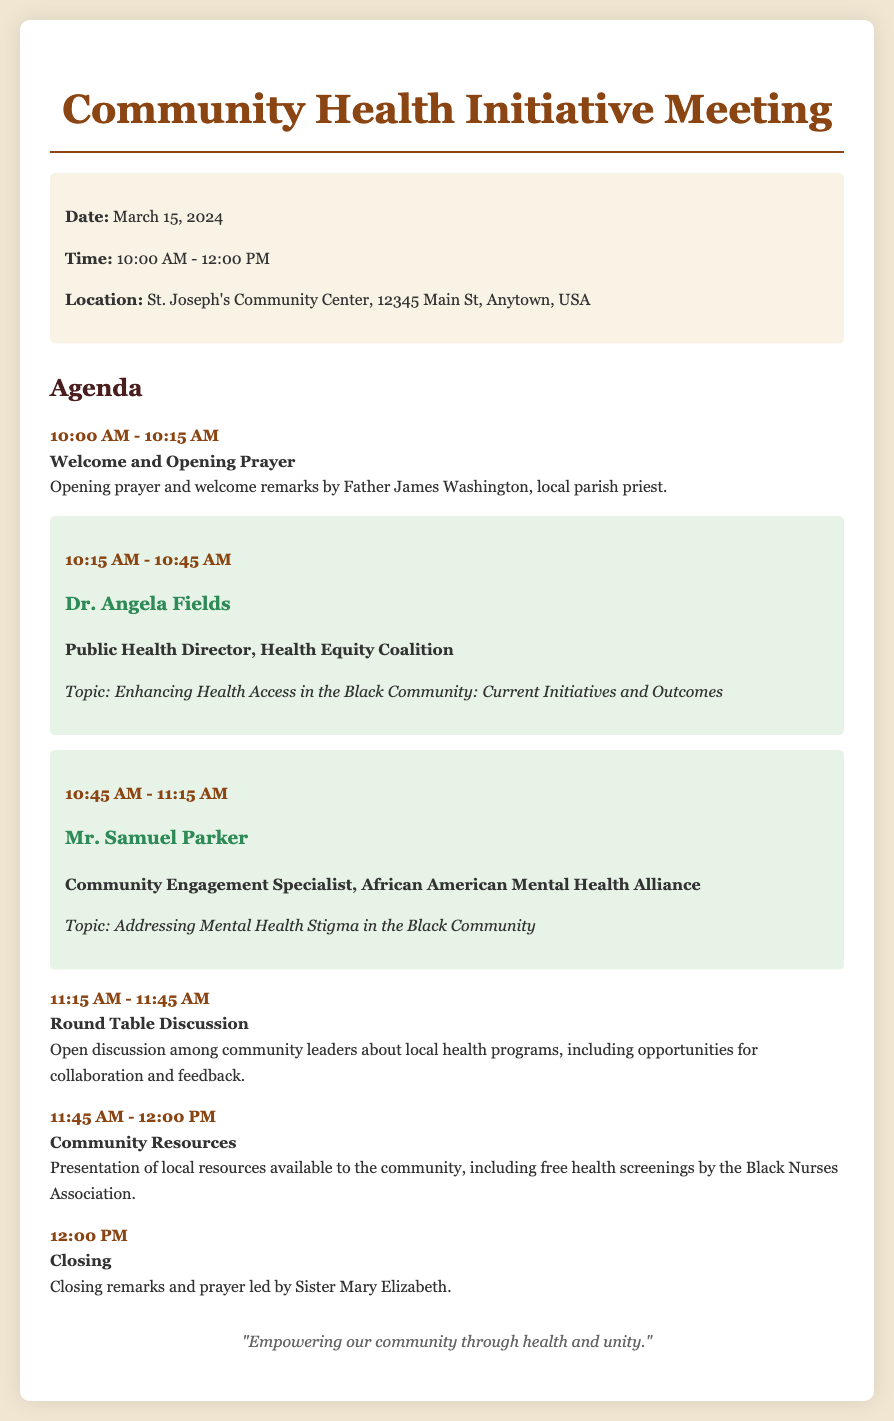What is the date of the meeting? The date of the meeting is specified in the document.
Answer: March 15, 2024 Who is giving the opening prayer? The document includes the name of the person giving the opening prayer.
Answer: Father James Washington What topic will Dr. Angela Fields discuss? The document mentions the topic that Dr. Angela Fields will cover during her presentation.
Answer: Enhancing Health Access in the Black Community: Current Initiatives and Outcomes What time does the round table discussion start? The start time for the round table discussion is clearly indicated in the document.
Answer: 11:15 AM Who leads the closing prayer? The document identifies the person who will lead the closing prayer at the end of the meeting.
Answer: Sister Mary Elizabeth Which organization is providing free health screenings? The document lists the organization responsible for providing free health screenings to the community.
Answer: Black Nurses Association What is the purpose of the round table discussion? The document describes the nature of the round table discussion.
Answer: Open discussion among community leaders about local health programs How long will the meeting last? The duration of the meeting is derived from the start and end times provided in the document.
Answer: 2 hours 